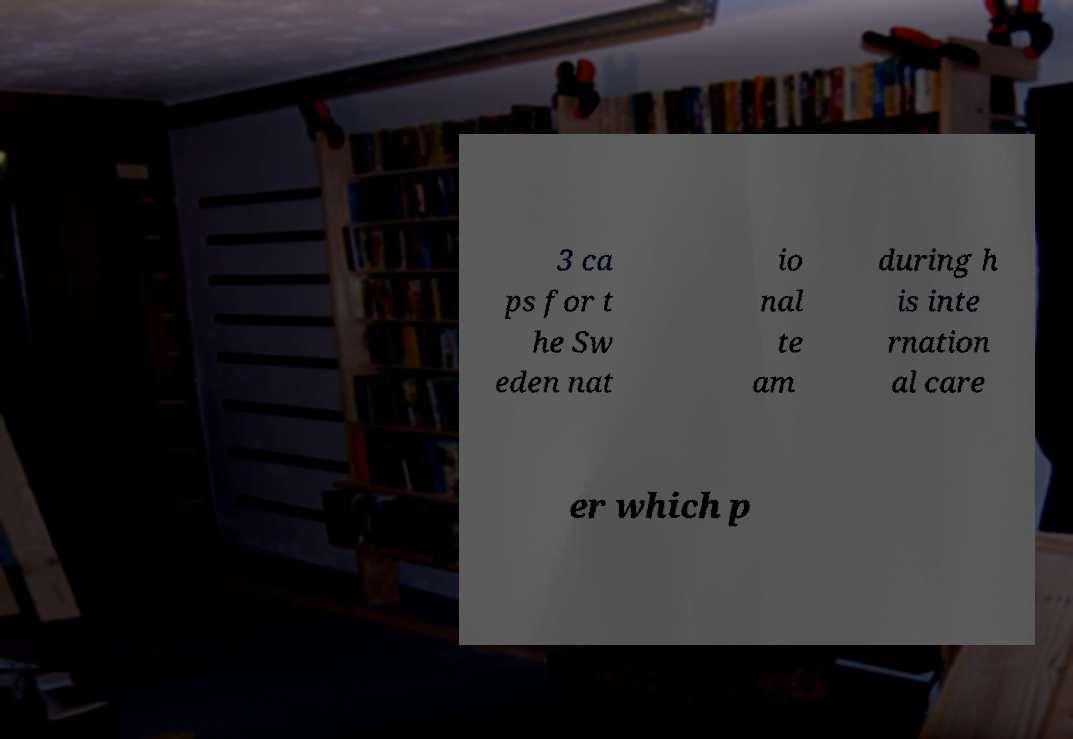Could you assist in decoding the text presented in this image and type it out clearly? 3 ca ps for t he Sw eden nat io nal te am during h is inte rnation al care er which p 